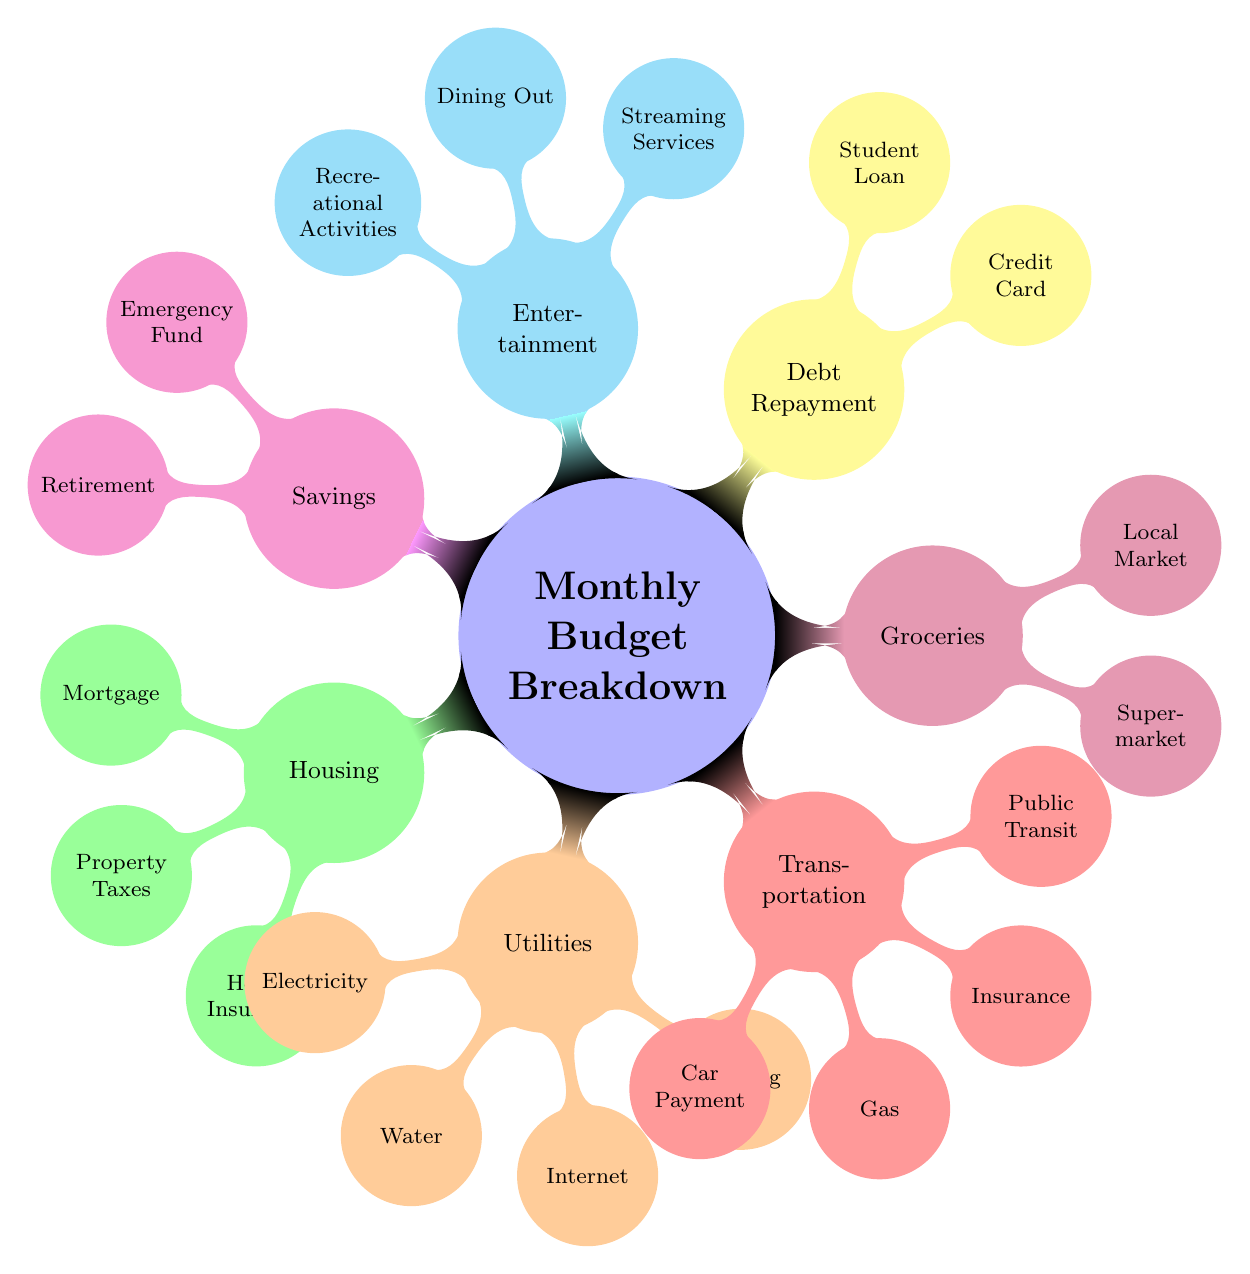What's the total number of main categories in the diagram? The main categories represented in the diagram are "Housing," "Utilities," "Transportation," "Groceries," "Debt Repayment," "Entertainment," and "Savings." Counting these categories gives a total of 7.
Answer: 7 Which category contains the "Mortgage" node? The "Mortgage" node is situated under the "Housing" category as indicated in the diagram where "Housing" is a parent node to "Mortgage."
Answer: Housing How many nodes are there in the "Entertainment" category? Within the "Entertainment" category, there are three nodes listed: "Streaming Services," "Dining Out," and "Recreational Activities." Thus, counting these nodes provides a total of 3.
Answer: 3 What type of expense is associated with "Emergency Fund"? The "Emergency Fund" is classified under the "Savings" category as depicted in the diagram. This indicates it is a type of savings expense.
Answer: Savings Which utility provider handles "Electricity" in the diagram? The provider for "Electricity" is listed as "EPCOR Electricity Bill" under the "Utilities" category, showing that EPCOR is responsible for electricity services.
Answer: EPCOR Compare the number of nodes under "Debt Repayment" with those under "Transportation." The "Debt Repayment" category has two nodes: "Credit Card" and "Student Loan." In contrast, the "Transportation" category has four nodes: "Car Payment," "Gas," "Insurance," and "Public Transit." Comparing these numbers shows that there are more nodes in "Transportation."
Answer: Transportation has more nodes Which category has the least number of nodes? The "Groceries" category contains the least number of nodes, with only two: "Supermarket" and "Local Market." This is fewer than any other categories in the diagram.
Answer: Groceries What are the two types of debt listed under "Debt Repayment"? The two types of debt under the "Debt Repayment" category are "Credit Card" and "Student Loan," as clearly indicated in their respective nodes.
Answer: Credit Card, Student Loan Which node relates to "Shaw" in the diagram? The node that relates to "Shaw" is "Internet," which is explicitly linked to Shaw Internet Service in the "Utilities" category.
Answer: Internet 